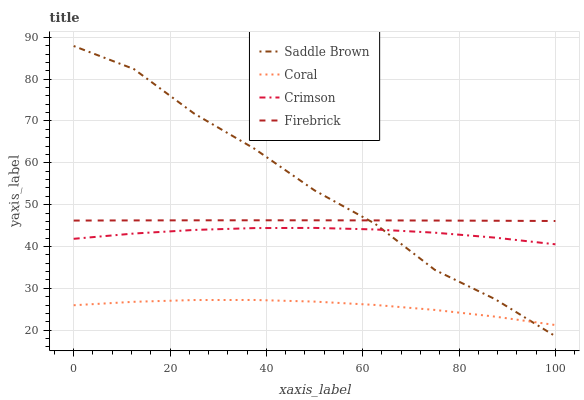Does Coral have the minimum area under the curve?
Answer yes or no. Yes. Does Saddle Brown have the maximum area under the curve?
Answer yes or no. Yes. Does Firebrick have the minimum area under the curve?
Answer yes or no. No. Does Firebrick have the maximum area under the curve?
Answer yes or no. No. Is Firebrick the smoothest?
Answer yes or no. Yes. Is Saddle Brown the roughest?
Answer yes or no. Yes. Is Coral the smoothest?
Answer yes or no. No. Is Coral the roughest?
Answer yes or no. No. Does Coral have the lowest value?
Answer yes or no. No. Does Saddle Brown have the highest value?
Answer yes or no. Yes. Does Firebrick have the highest value?
Answer yes or no. No. Is Coral less than Crimson?
Answer yes or no. Yes. Is Firebrick greater than Coral?
Answer yes or no. Yes. Does Saddle Brown intersect Firebrick?
Answer yes or no. Yes. Is Saddle Brown less than Firebrick?
Answer yes or no. No. Is Saddle Brown greater than Firebrick?
Answer yes or no. No. Does Coral intersect Crimson?
Answer yes or no. No. 